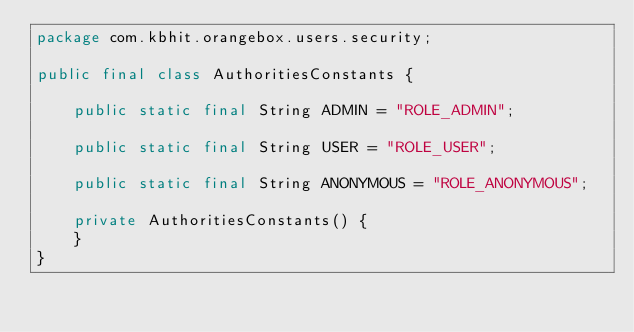<code> <loc_0><loc_0><loc_500><loc_500><_Java_>package com.kbhit.orangebox.users.security;

public final class AuthoritiesConstants {

    public static final String ADMIN = "ROLE_ADMIN";

    public static final String USER = "ROLE_USER";

    public static final String ANONYMOUS = "ROLE_ANONYMOUS";

    private AuthoritiesConstants() {
    }
}
</code> 